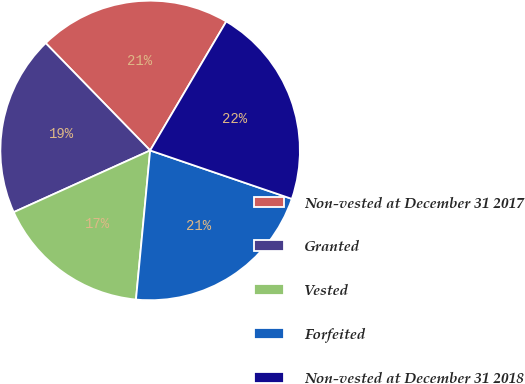<chart> <loc_0><loc_0><loc_500><loc_500><pie_chart><fcel>Non-vested at December 31 2017<fcel>Granted<fcel>Vested<fcel>Forfeited<fcel>Non-vested at December 31 2018<nl><fcel>20.77%<fcel>19.48%<fcel>16.73%<fcel>21.27%<fcel>21.76%<nl></chart> 